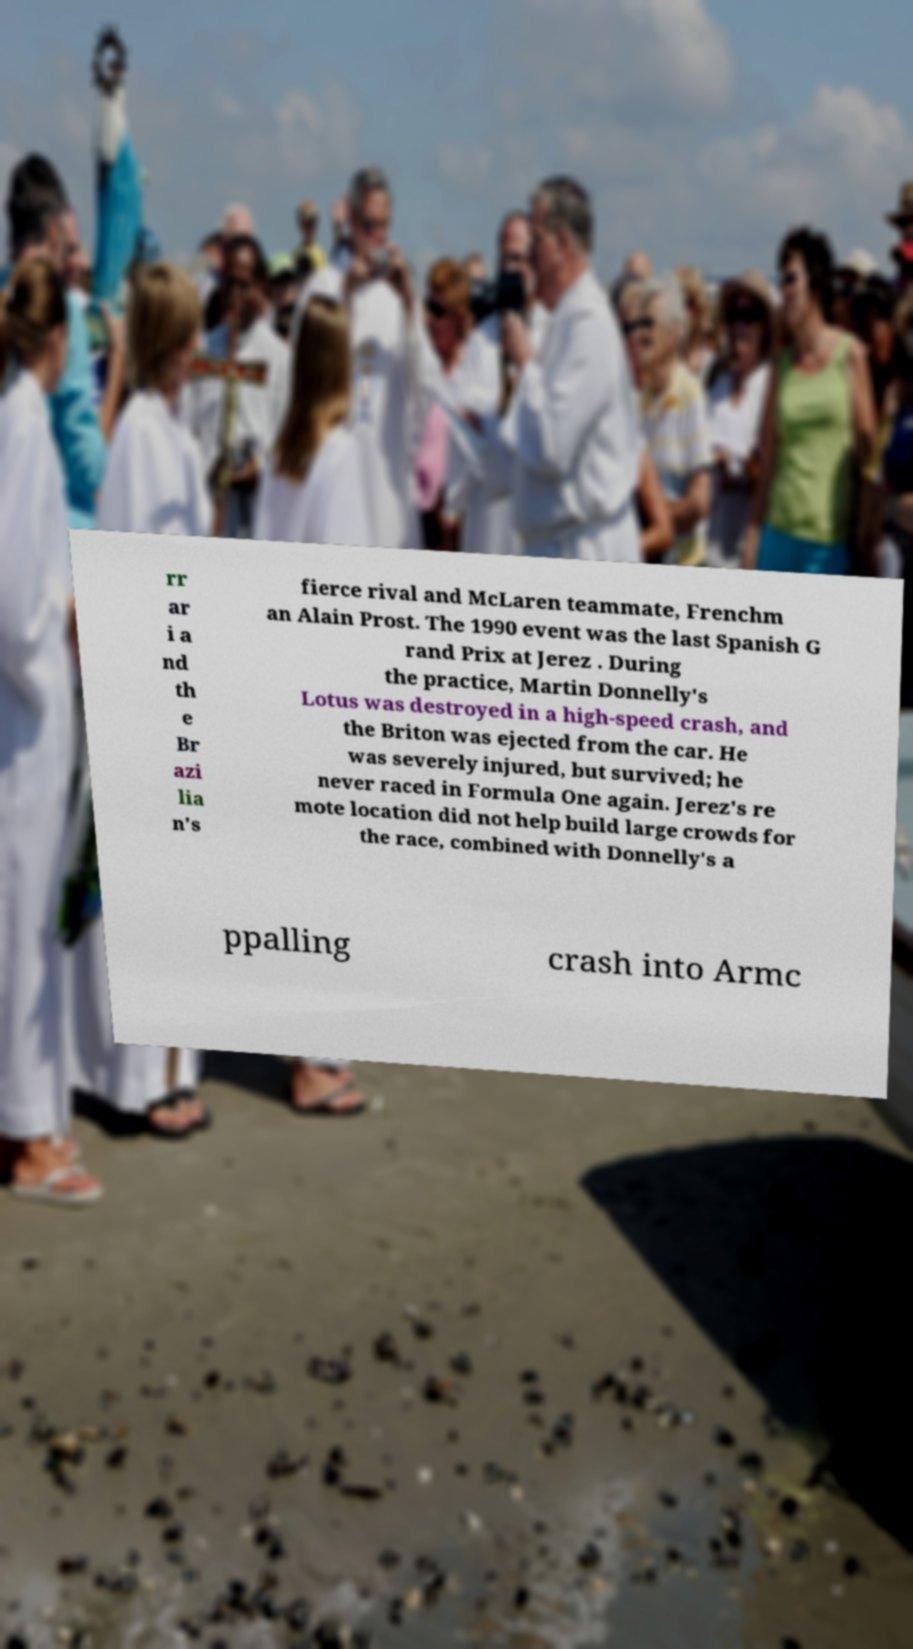Can you read and provide the text displayed in the image?This photo seems to have some interesting text. Can you extract and type it out for me? rr ar i a nd th e Br azi lia n's fierce rival and McLaren teammate, Frenchm an Alain Prost. The 1990 event was the last Spanish G rand Prix at Jerez . During the practice, Martin Donnelly's Lotus was destroyed in a high-speed crash, and the Briton was ejected from the car. He was severely injured, but survived; he never raced in Formula One again. Jerez's re mote location did not help build large crowds for the race, combined with Donnelly's a ppalling crash into Armc 